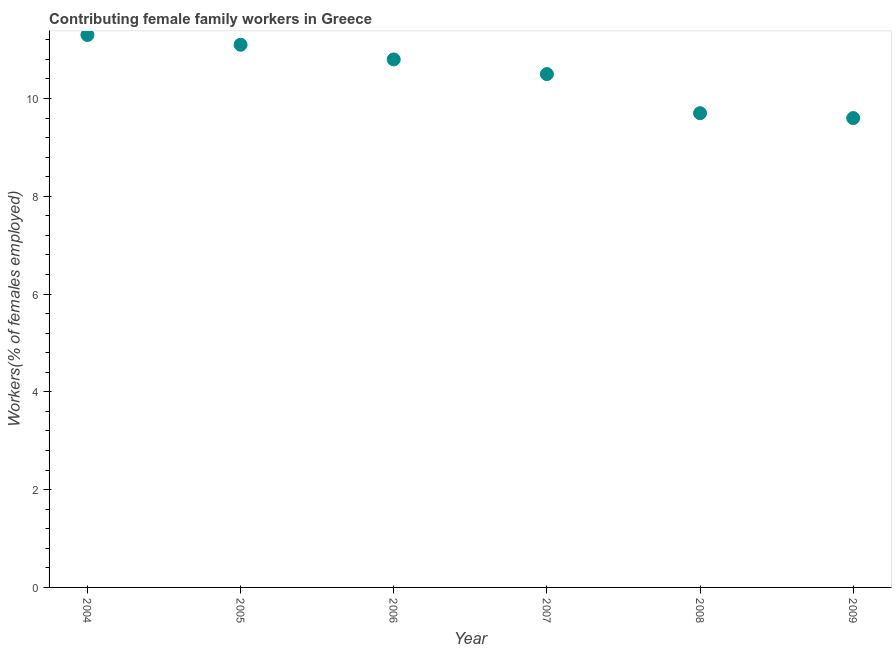What is the contributing female family workers in 2005?
Provide a short and direct response. 11.1. Across all years, what is the maximum contributing female family workers?
Your answer should be very brief. 11.3. Across all years, what is the minimum contributing female family workers?
Offer a very short reply. 9.6. What is the sum of the contributing female family workers?
Ensure brevity in your answer.  63. What is the difference between the contributing female family workers in 2005 and 2007?
Your answer should be compact. 0.6. What is the average contributing female family workers per year?
Offer a terse response. 10.5. What is the median contributing female family workers?
Offer a very short reply. 10.65. What is the ratio of the contributing female family workers in 2004 to that in 2006?
Keep it short and to the point. 1.05. Is the difference between the contributing female family workers in 2004 and 2009 greater than the difference between any two years?
Make the answer very short. Yes. What is the difference between the highest and the second highest contributing female family workers?
Give a very brief answer. 0.2. What is the difference between the highest and the lowest contributing female family workers?
Your answer should be compact. 1.7. In how many years, is the contributing female family workers greater than the average contributing female family workers taken over all years?
Your response must be concise. 3. How many years are there in the graph?
Keep it short and to the point. 6. What is the difference between two consecutive major ticks on the Y-axis?
Keep it short and to the point. 2. Are the values on the major ticks of Y-axis written in scientific E-notation?
Ensure brevity in your answer.  No. What is the title of the graph?
Make the answer very short. Contributing female family workers in Greece. What is the label or title of the X-axis?
Ensure brevity in your answer.  Year. What is the label or title of the Y-axis?
Provide a succinct answer. Workers(% of females employed). What is the Workers(% of females employed) in 2004?
Give a very brief answer. 11.3. What is the Workers(% of females employed) in 2005?
Make the answer very short. 11.1. What is the Workers(% of females employed) in 2006?
Give a very brief answer. 10.8. What is the Workers(% of females employed) in 2007?
Provide a succinct answer. 10.5. What is the Workers(% of females employed) in 2008?
Give a very brief answer. 9.7. What is the Workers(% of females employed) in 2009?
Make the answer very short. 9.6. What is the difference between the Workers(% of females employed) in 2004 and 2005?
Offer a very short reply. 0.2. What is the difference between the Workers(% of females employed) in 2004 and 2007?
Your answer should be compact. 0.8. What is the difference between the Workers(% of females employed) in 2004 and 2008?
Keep it short and to the point. 1.6. What is the difference between the Workers(% of females employed) in 2004 and 2009?
Give a very brief answer. 1.7. What is the difference between the Workers(% of females employed) in 2005 and 2006?
Your response must be concise. 0.3. What is the difference between the Workers(% of females employed) in 2005 and 2009?
Your answer should be compact. 1.5. What is the difference between the Workers(% of females employed) in 2006 and 2007?
Offer a terse response. 0.3. What is the difference between the Workers(% of females employed) in 2007 and 2008?
Give a very brief answer. 0.8. What is the difference between the Workers(% of females employed) in 2007 and 2009?
Your response must be concise. 0.9. What is the difference between the Workers(% of females employed) in 2008 and 2009?
Your response must be concise. 0.1. What is the ratio of the Workers(% of females employed) in 2004 to that in 2005?
Offer a terse response. 1.02. What is the ratio of the Workers(% of females employed) in 2004 to that in 2006?
Make the answer very short. 1.05. What is the ratio of the Workers(% of females employed) in 2004 to that in 2007?
Your answer should be compact. 1.08. What is the ratio of the Workers(% of females employed) in 2004 to that in 2008?
Offer a terse response. 1.17. What is the ratio of the Workers(% of females employed) in 2004 to that in 2009?
Keep it short and to the point. 1.18. What is the ratio of the Workers(% of females employed) in 2005 to that in 2006?
Keep it short and to the point. 1.03. What is the ratio of the Workers(% of females employed) in 2005 to that in 2007?
Make the answer very short. 1.06. What is the ratio of the Workers(% of females employed) in 2005 to that in 2008?
Your response must be concise. 1.14. What is the ratio of the Workers(% of females employed) in 2005 to that in 2009?
Ensure brevity in your answer.  1.16. What is the ratio of the Workers(% of females employed) in 2006 to that in 2007?
Make the answer very short. 1.03. What is the ratio of the Workers(% of females employed) in 2006 to that in 2008?
Provide a succinct answer. 1.11. What is the ratio of the Workers(% of females employed) in 2006 to that in 2009?
Your answer should be very brief. 1.12. What is the ratio of the Workers(% of females employed) in 2007 to that in 2008?
Make the answer very short. 1.08. What is the ratio of the Workers(% of females employed) in 2007 to that in 2009?
Your response must be concise. 1.09. What is the ratio of the Workers(% of females employed) in 2008 to that in 2009?
Provide a short and direct response. 1.01. 